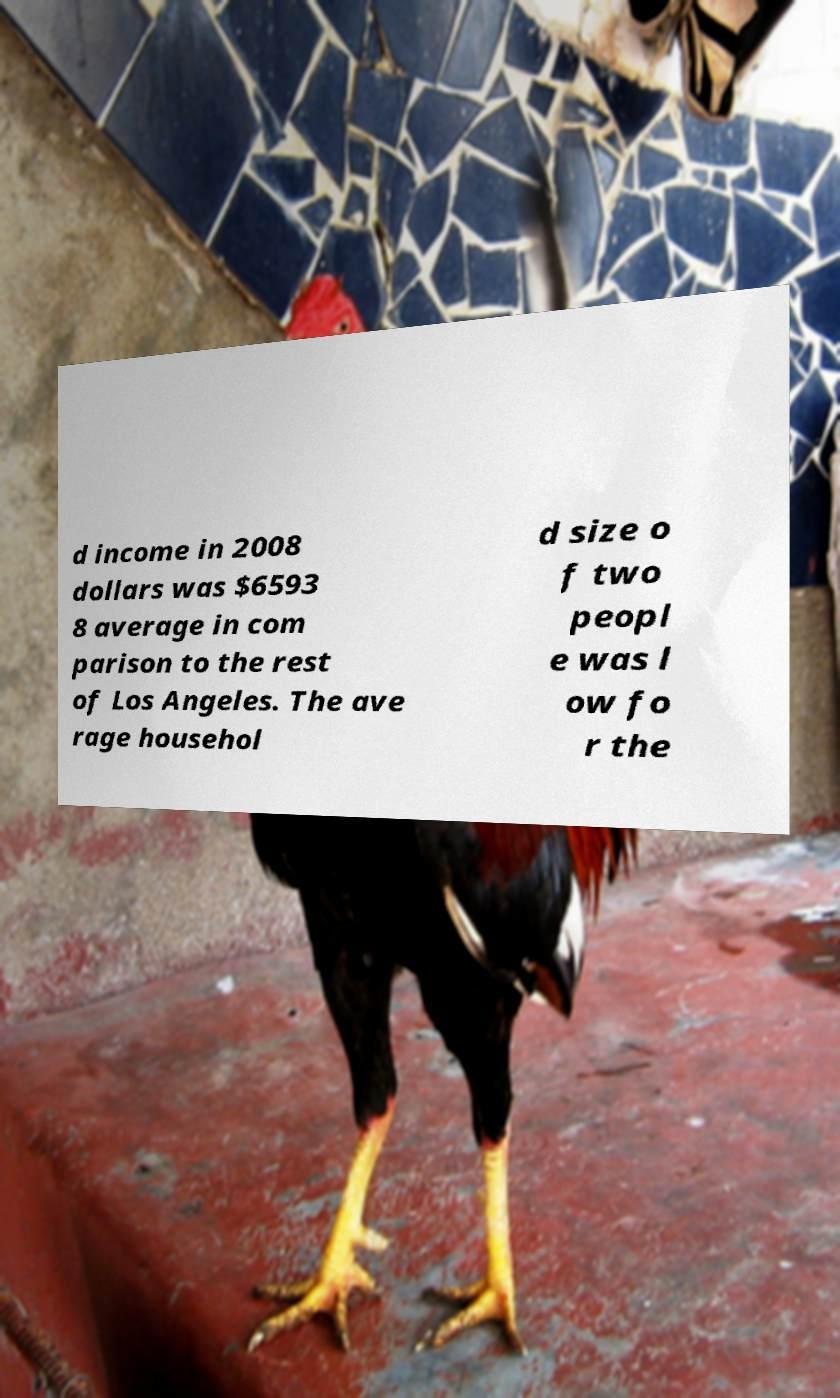Please identify and transcribe the text found in this image. d income in 2008 dollars was $6593 8 average in com parison to the rest of Los Angeles. The ave rage househol d size o f two peopl e was l ow fo r the 